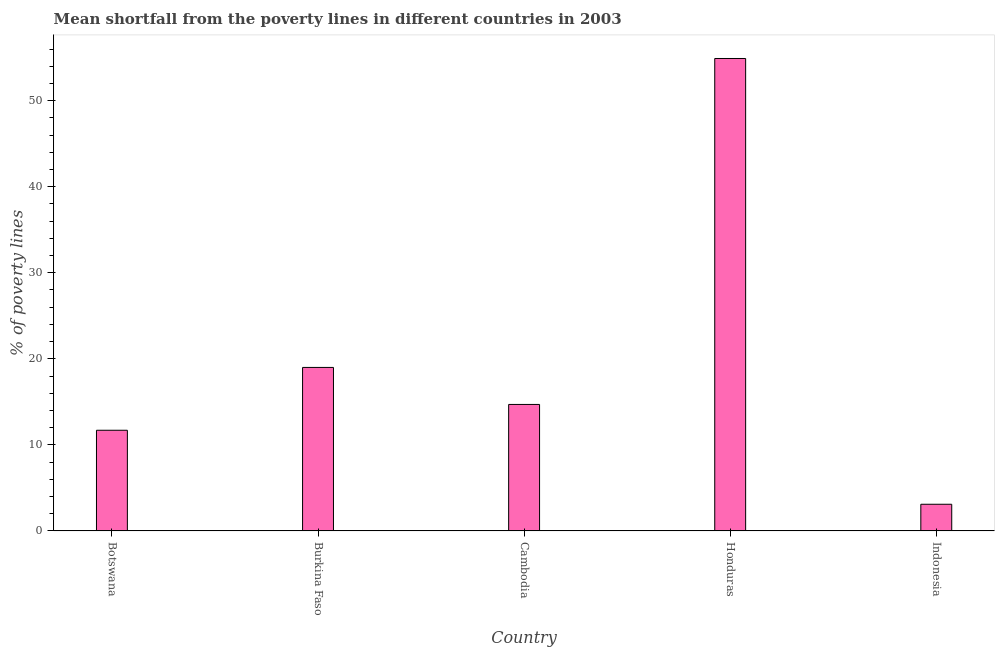Does the graph contain any zero values?
Ensure brevity in your answer.  No. Does the graph contain grids?
Give a very brief answer. No. What is the title of the graph?
Your answer should be very brief. Mean shortfall from the poverty lines in different countries in 2003. What is the label or title of the Y-axis?
Provide a short and direct response. % of poverty lines. What is the poverty gap at national poverty lines in Botswana?
Offer a very short reply. 11.7. Across all countries, what is the maximum poverty gap at national poverty lines?
Your answer should be compact. 54.9. Across all countries, what is the minimum poverty gap at national poverty lines?
Your answer should be compact. 3.1. In which country was the poverty gap at national poverty lines maximum?
Make the answer very short. Honduras. What is the sum of the poverty gap at national poverty lines?
Give a very brief answer. 103.4. What is the average poverty gap at national poverty lines per country?
Your answer should be compact. 20.68. What is the ratio of the poverty gap at national poverty lines in Burkina Faso to that in Indonesia?
Your response must be concise. 6.13. Is the poverty gap at national poverty lines in Botswana less than that in Cambodia?
Provide a succinct answer. Yes. Is the difference between the poverty gap at national poverty lines in Botswana and Indonesia greater than the difference between any two countries?
Your answer should be very brief. No. What is the difference between the highest and the second highest poverty gap at national poverty lines?
Your answer should be compact. 35.9. Is the sum of the poverty gap at national poverty lines in Honduras and Indonesia greater than the maximum poverty gap at national poverty lines across all countries?
Ensure brevity in your answer.  Yes. What is the difference between the highest and the lowest poverty gap at national poverty lines?
Offer a very short reply. 51.8. Are the values on the major ticks of Y-axis written in scientific E-notation?
Provide a short and direct response. No. What is the % of poverty lines in Botswana?
Your answer should be compact. 11.7. What is the % of poverty lines in Honduras?
Provide a succinct answer. 54.9. What is the % of poverty lines in Indonesia?
Ensure brevity in your answer.  3.1. What is the difference between the % of poverty lines in Botswana and Burkina Faso?
Provide a short and direct response. -7.3. What is the difference between the % of poverty lines in Botswana and Cambodia?
Offer a very short reply. -3. What is the difference between the % of poverty lines in Botswana and Honduras?
Your response must be concise. -43.2. What is the difference between the % of poverty lines in Botswana and Indonesia?
Provide a short and direct response. 8.6. What is the difference between the % of poverty lines in Burkina Faso and Honduras?
Offer a very short reply. -35.9. What is the difference between the % of poverty lines in Cambodia and Honduras?
Offer a very short reply. -40.2. What is the difference between the % of poverty lines in Cambodia and Indonesia?
Ensure brevity in your answer.  11.6. What is the difference between the % of poverty lines in Honduras and Indonesia?
Ensure brevity in your answer.  51.8. What is the ratio of the % of poverty lines in Botswana to that in Burkina Faso?
Make the answer very short. 0.62. What is the ratio of the % of poverty lines in Botswana to that in Cambodia?
Give a very brief answer. 0.8. What is the ratio of the % of poverty lines in Botswana to that in Honduras?
Give a very brief answer. 0.21. What is the ratio of the % of poverty lines in Botswana to that in Indonesia?
Your answer should be compact. 3.77. What is the ratio of the % of poverty lines in Burkina Faso to that in Cambodia?
Keep it short and to the point. 1.29. What is the ratio of the % of poverty lines in Burkina Faso to that in Honduras?
Offer a terse response. 0.35. What is the ratio of the % of poverty lines in Burkina Faso to that in Indonesia?
Your response must be concise. 6.13. What is the ratio of the % of poverty lines in Cambodia to that in Honduras?
Your answer should be compact. 0.27. What is the ratio of the % of poverty lines in Cambodia to that in Indonesia?
Give a very brief answer. 4.74. What is the ratio of the % of poverty lines in Honduras to that in Indonesia?
Provide a succinct answer. 17.71. 